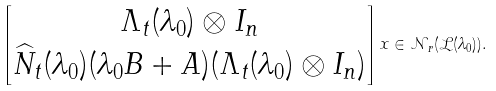<formula> <loc_0><loc_0><loc_500><loc_500>\begin{bmatrix} \Lambda _ { t } ( \lambda _ { 0 } ) \otimes I _ { n } \\ \widehat { N } _ { t } ( \lambda _ { 0 } ) ( \lambda _ { 0 } B + A ) ( \Lambda _ { t } ( \lambda _ { 0 } ) \otimes I _ { n } ) \end{bmatrix} x \in \mathcal { N } _ { r } ( \mathcal { L } ( \lambda _ { 0 } ) ) .</formula> 